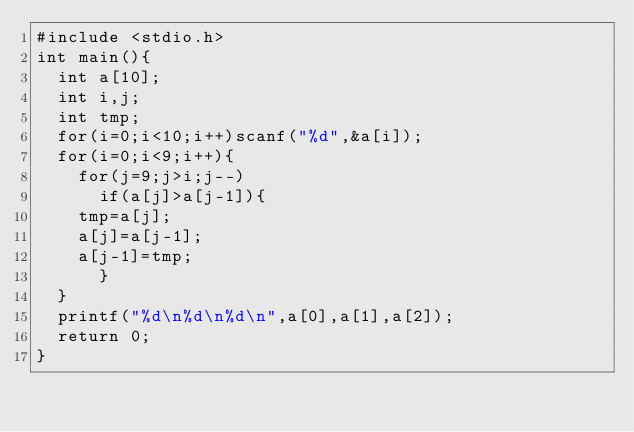<code> <loc_0><loc_0><loc_500><loc_500><_C_>#include <stdio.h>
int main(){
  int a[10];
  int i,j;
  int tmp;
  for(i=0;i<10;i++)scanf("%d",&a[i]);
  for(i=0;i<9;i++){
    for(j=9;j>i;j--)
      if(a[j]>a[j-1]){
	tmp=a[j];
	a[j]=a[j-1];
	a[j-1]=tmp;
      }
  }
  printf("%d\n%d\n%d\n",a[0],a[1],a[2]);
  return 0;
}</code> 